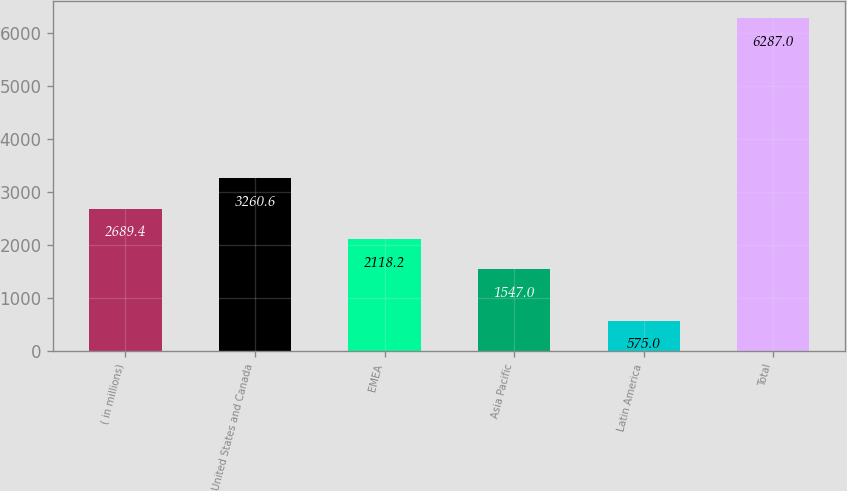<chart> <loc_0><loc_0><loc_500><loc_500><bar_chart><fcel>( in millions)<fcel>United States and Canada<fcel>EMEA<fcel>Asia Pacific<fcel>Latin America<fcel>Total<nl><fcel>2689.4<fcel>3260.6<fcel>2118.2<fcel>1547<fcel>575<fcel>6287<nl></chart> 